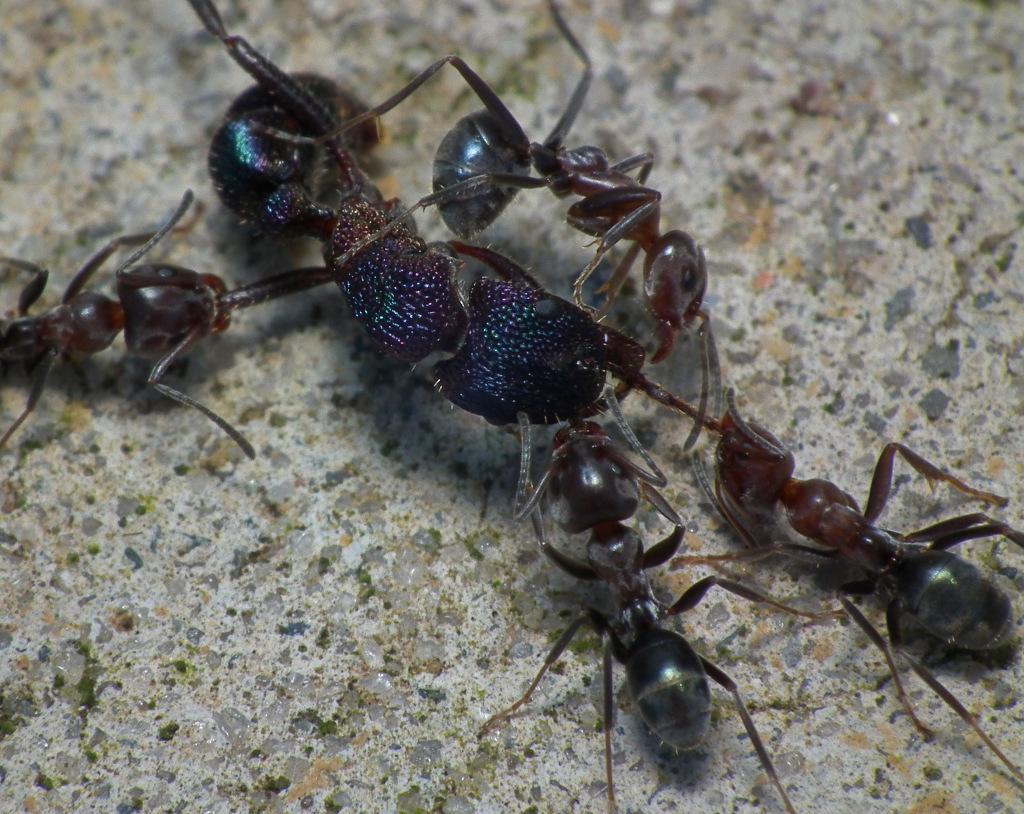How would you summarize this image in a sentence or two? In this image I can see few ants, they are in black and brown color and the ants are on the cream color surface. 